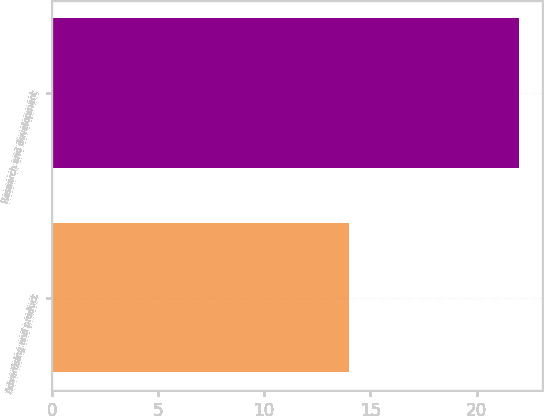Convert chart to OTSL. <chart><loc_0><loc_0><loc_500><loc_500><bar_chart><fcel>Advertising and product<fcel>Research and development<nl><fcel>14<fcel>22<nl></chart> 